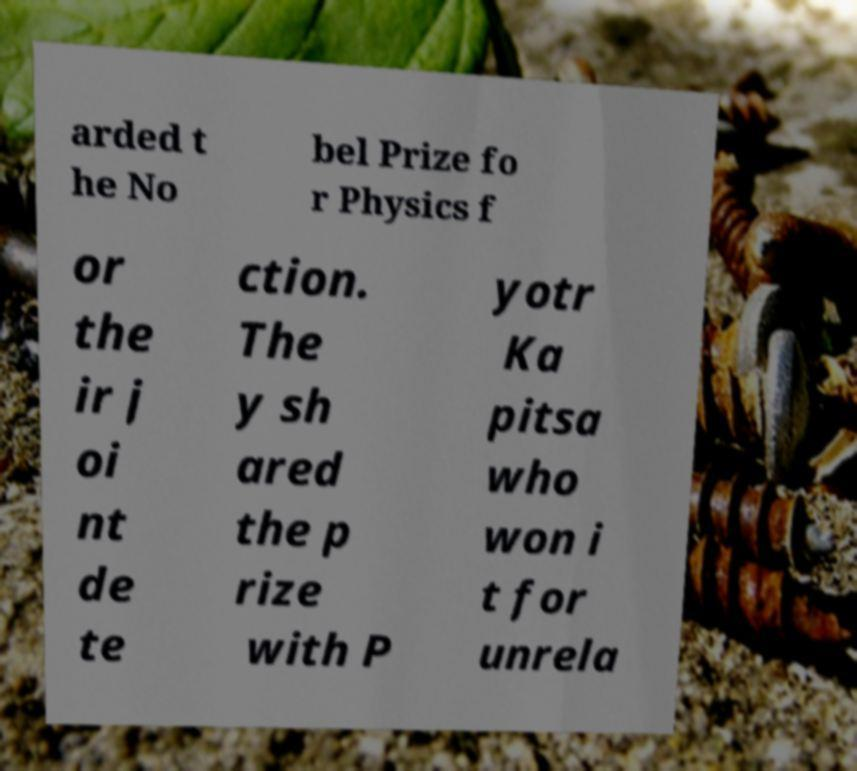Please read and relay the text visible in this image. What does it say? arded t he No bel Prize fo r Physics f or the ir j oi nt de te ction. The y sh ared the p rize with P yotr Ka pitsa who won i t for unrela 